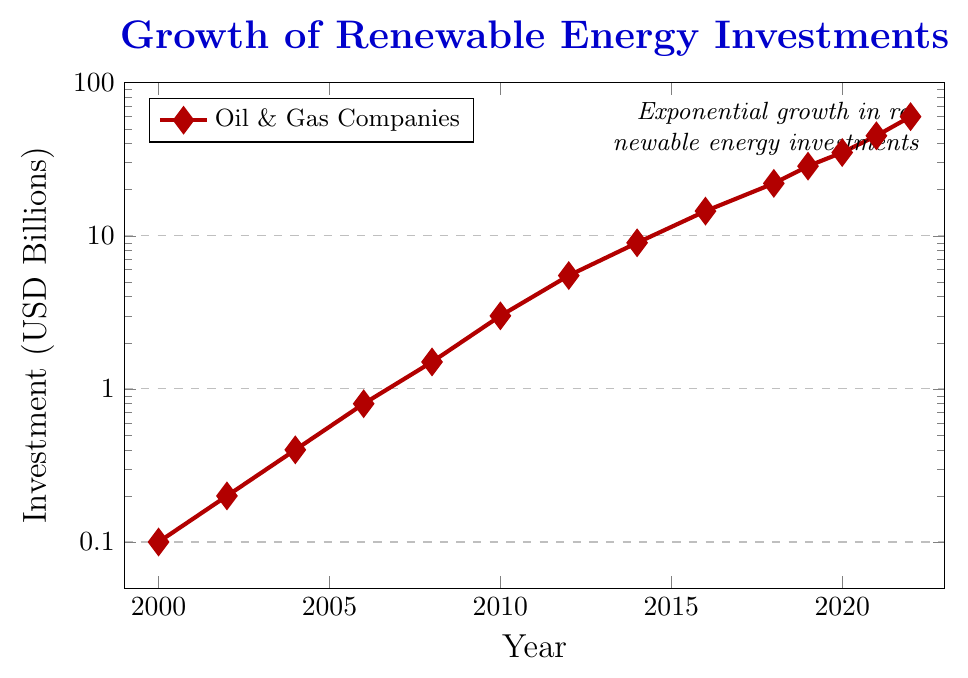When did investments in renewable energy surpass 10 billion USD? From the data points on the plot, investments reached 14.5 billion USD in 2016. So the year when investments surpassed 10 billion USD was 2016.
Answer: 2016 What’s the overall growth trend of renewable energy investments from 2000 to 2022? Observing the red line on the semilogarithmic chart, the data shows exponential growth in renewable energy investments from 0.1 billion in 2000 to 60 billion in 2022.
Answer: Exponential growth How much did renewable energy investments increase between 2010 and 2020? From the plot, investments were 3 billion USD in 2010 and 35 billion USD in 2020. The increase is 35 - 3 = 32 billion USD.
Answer: 32 billion USD In which year did the investment reach its highest single-year increase, based on the visible data points? Between 2021 and 2022, the investment increased from 45 billion to 60 billion, a 15 billion jump. This is the largest visible single-year increase.
Answer: Between 2021 and 2022 What was the approximate investment value in 2008? Looking at the red diamond marker on the chart for the year 2008, it is slightly below the 1.5 billion USD mark. So, the investment value in 2008 was approximately 1.5 billion USD.
Answer: Approximately 1.5 billion USD Compare the renewable energy investment in 2010 with that in 2012. How many times larger was the 2012 investment compared to 2010? Renewable energy investment in 2012 was 5.5 billion USD, and in 2010 it was 3 billion USD. The ratio is 5.5 / 3 = 1.83 times larger.
Answer: 1.83 times larger What is the average annual investment growth between 2016 and 2022? The investment in 2016 was 14.5 billion USD, and in 2022, it was 60 billion USD. The annual growth over 6 years is (60 - 14.5) / 6 = 7.58 billion USD per year on average.
Answer: 7.58 billion USD per year Which year had an investment of approximately 9 billion USD? From the plot, the investment in 2014 reached approximately 9 billion USD.
Answer: 2014 How many years did it take for investments to grow from around 1 billion USD to 10 billion USD? Investments were approximately 1 billion USD in 2008 and surpassed 10 billion USD in 2016. It took about 8 years to grow from 1 billion to 10 billion USD.
Answer: 8 years By what factor did the investment grow from 2000 to 2022? In 2000, the investment was 0.1 billion USD, and in 2022, it was 60 billion USD. The factor of growth is 60 / 0.1 = 600 times.
Answer: 600 times 